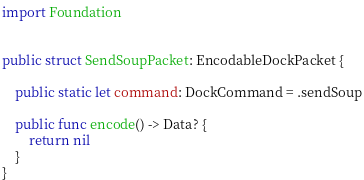<code> <loc_0><loc_0><loc_500><loc_500><_Swift_>import Foundation


public struct SendSoupPacket: EncodableDockPacket {

    public static let command: DockCommand = .sendSoup

    public func encode() -> Data? {
        return nil
    }
}

</code> 